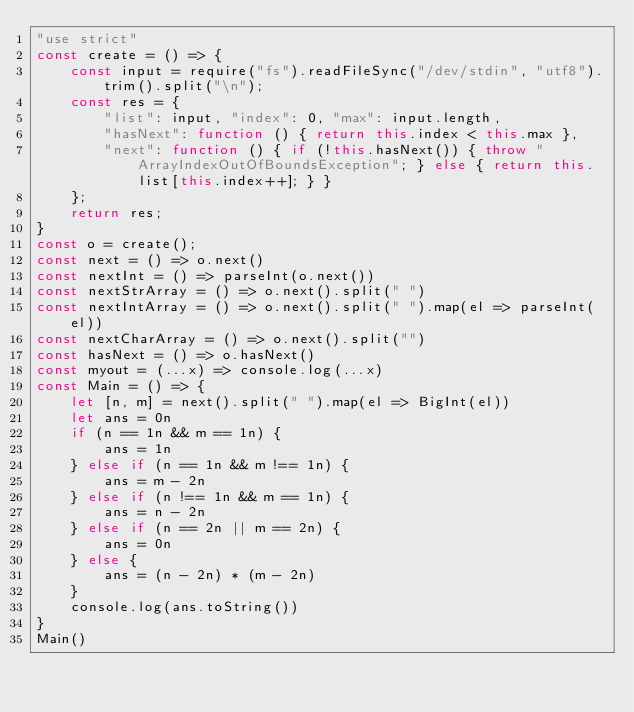<code> <loc_0><loc_0><loc_500><loc_500><_JavaScript_>"use strict"
const create = () => {
    const input = require("fs").readFileSync("/dev/stdin", "utf8").trim().split("\n");
    const res = {
        "list": input, "index": 0, "max": input.length,
        "hasNext": function () { return this.index < this.max },
        "next": function () { if (!this.hasNext()) { throw "ArrayIndexOutOfBoundsException"; } else { return this.list[this.index++]; } }
    };
    return res;
}
const o = create();
const next = () => o.next()
const nextInt = () => parseInt(o.next())
const nextStrArray = () => o.next().split(" ")
const nextIntArray = () => o.next().split(" ").map(el => parseInt(el))
const nextCharArray = () => o.next().split("")
const hasNext = () => o.hasNext()
const myout = (...x) => console.log(...x)
const Main = () => {
    let [n, m] = next().split(" ").map(el => BigInt(el))
    let ans = 0n
    if (n == 1n && m == 1n) {
        ans = 1n
    } else if (n == 1n && m !== 1n) {
        ans = m - 2n
    } else if (n !== 1n && m == 1n) {
        ans = n - 2n
    } else if (n == 2n || m == 2n) {
        ans = 0n
    } else {
        ans = (n - 2n) * (m - 2n)
    }
    console.log(ans.toString())
}
Main()
</code> 